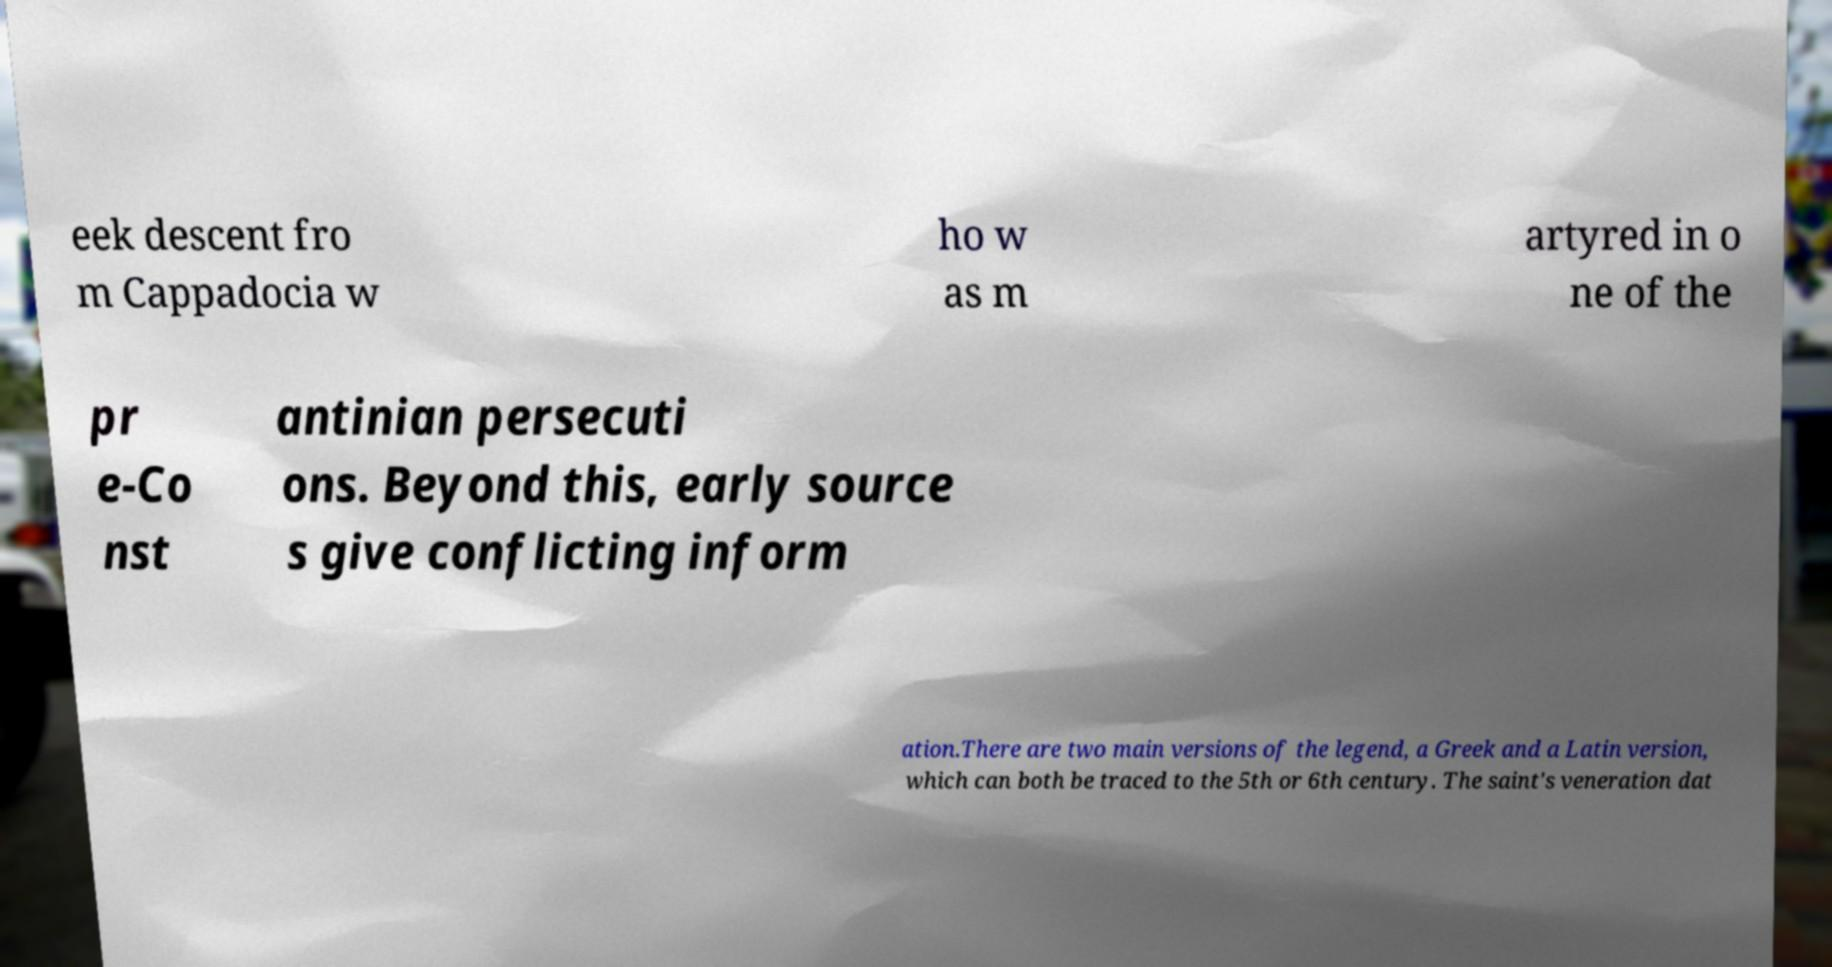Can you accurately transcribe the text from the provided image for me? eek descent fro m Cappadocia w ho w as m artyred in o ne of the pr e-Co nst antinian persecuti ons. Beyond this, early source s give conflicting inform ation.There are two main versions of the legend, a Greek and a Latin version, which can both be traced to the 5th or 6th century. The saint's veneration dat 